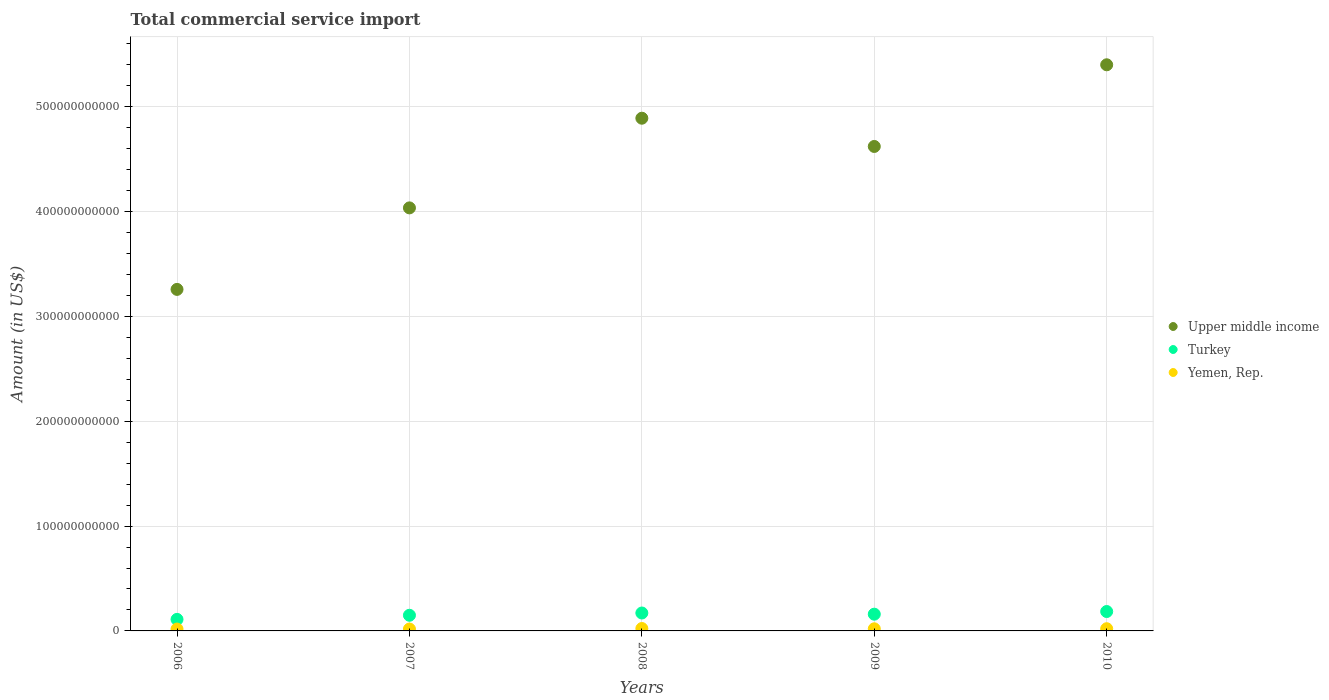How many different coloured dotlines are there?
Provide a succinct answer. 3. Is the number of dotlines equal to the number of legend labels?
Offer a very short reply. Yes. What is the total commercial service import in Turkey in 2008?
Provide a succinct answer. 1.71e+1. Across all years, what is the maximum total commercial service import in Yemen, Rep.?
Your answer should be compact. 2.29e+09. Across all years, what is the minimum total commercial service import in Upper middle income?
Keep it short and to the point. 3.26e+11. In which year was the total commercial service import in Turkey minimum?
Give a very brief answer. 2006. What is the total total commercial service import in Yemen, Rep. in the graph?
Offer a terse response. 1.00e+1. What is the difference between the total commercial service import in Upper middle income in 2009 and that in 2010?
Your response must be concise. -7.79e+1. What is the difference between the total commercial service import in Yemen, Rep. in 2009 and the total commercial service import in Turkey in 2007?
Ensure brevity in your answer.  -1.29e+1. What is the average total commercial service import in Upper middle income per year?
Make the answer very short. 4.44e+11. In the year 2008, what is the difference between the total commercial service import in Yemen, Rep. and total commercial service import in Upper middle income?
Your answer should be compact. -4.87e+11. What is the ratio of the total commercial service import in Turkey in 2009 to that in 2010?
Your answer should be compact. 0.86. Is the total commercial service import in Yemen, Rep. in 2006 less than that in 2010?
Ensure brevity in your answer.  Yes. What is the difference between the highest and the second highest total commercial service import in Turkey?
Give a very brief answer. 1.42e+09. What is the difference between the highest and the lowest total commercial service import in Upper middle income?
Your response must be concise. 2.14e+11. Is the sum of the total commercial service import in Yemen, Rep. in 2008 and 2010 greater than the maximum total commercial service import in Turkey across all years?
Ensure brevity in your answer.  No. Is it the case that in every year, the sum of the total commercial service import in Yemen, Rep. and total commercial service import in Turkey  is greater than the total commercial service import in Upper middle income?
Give a very brief answer. No. Does the total commercial service import in Yemen, Rep. monotonically increase over the years?
Provide a short and direct response. No. Is the total commercial service import in Turkey strictly greater than the total commercial service import in Upper middle income over the years?
Keep it short and to the point. No. What is the difference between two consecutive major ticks on the Y-axis?
Your answer should be compact. 1.00e+11. Are the values on the major ticks of Y-axis written in scientific E-notation?
Keep it short and to the point. No. Where does the legend appear in the graph?
Make the answer very short. Center right. How are the legend labels stacked?
Give a very brief answer. Vertical. What is the title of the graph?
Offer a terse response. Total commercial service import. What is the Amount (in US$) in Upper middle income in 2006?
Offer a terse response. 3.26e+11. What is the Amount (in US$) in Turkey in 2006?
Your response must be concise. 1.10e+1. What is the Amount (in US$) in Yemen, Rep. in 2006?
Ensure brevity in your answer.  1.80e+09. What is the Amount (in US$) in Upper middle income in 2007?
Give a very brief answer. 4.04e+11. What is the Amount (in US$) of Turkey in 2007?
Offer a very short reply. 1.49e+1. What is the Amount (in US$) in Yemen, Rep. in 2007?
Your answer should be very brief. 1.81e+09. What is the Amount (in US$) of Upper middle income in 2008?
Provide a short and direct response. 4.89e+11. What is the Amount (in US$) of Turkey in 2008?
Your answer should be very brief. 1.71e+1. What is the Amount (in US$) in Yemen, Rep. in 2008?
Give a very brief answer. 2.29e+09. What is the Amount (in US$) in Upper middle income in 2009?
Offer a terse response. 4.62e+11. What is the Amount (in US$) in Turkey in 2009?
Make the answer very short. 1.60e+1. What is the Amount (in US$) of Yemen, Rep. in 2009?
Your answer should be compact. 2.03e+09. What is the Amount (in US$) of Upper middle income in 2010?
Ensure brevity in your answer.  5.40e+11. What is the Amount (in US$) of Turkey in 2010?
Keep it short and to the point. 1.85e+1. What is the Amount (in US$) of Yemen, Rep. in 2010?
Give a very brief answer. 2.10e+09. Across all years, what is the maximum Amount (in US$) in Upper middle income?
Your answer should be compact. 5.40e+11. Across all years, what is the maximum Amount (in US$) in Turkey?
Keep it short and to the point. 1.85e+1. Across all years, what is the maximum Amount (in US$) of Yemen, Rep.?
Provide a succinct answer. 2.29e+09. Across all years, what is the minimum Amount (in US$) of Upper middle income?
Keep it short and to the point. 3.26e+11. Across all years, what is the minimum Amount (in US$) in Turkey?
Ensure brevity in your answer.  1.10e+1. Across all years, what is the minimum Amount (in US$) of Yemen, Rep.?
Ensure brevity in your answer.  1.80e+09. What is the total Amount (in US$) in Upper middle income in the graph?
Your answer should be very brief. 2.22e+12. What is the total Amount (in US$) in Turkey in the graph?
Give a very brief answer. 7.75e+1. What is the total Amount (in US$) in Yemen, Rep. in the graph?
Your answer should be compact. 1.00e+1. What is the difference between the Amount (in US$) of Upper middle income in 2006 and that in 2007?
Make the answer very short. -7.78e+1. What is the difference between the Amount (in US$) in Turkey in 2006 and that in 2007?
Your answer should be compact. -3.92e+09. What is the difference between the Amount (in US$) in Yemen, Rep. in 2006 and that in 2007?
Your answer should be very brief. -1.06e+07. What is the difference between the Amount (in US$) in Upper middle income in 2006 and that in 2008?
Ensure brevity in your answer.  -1.63e+11. What is the difference between the Amount (in US$) of Turkey in 2006 and that in 2008?
Your response must be concise. -6.08e+09. What is the difference between the Amount (in US$) of Yemen, Rep. in 2006 and that in 2008?
Ensure brevity in your answer.  -4.89e+08. What is the difference between the Amount (in US$) of Upper middle income in 2006 and that in 2009?
Make the answer very short. -1.36e+11. What is the difference between the Amount (in US$) of Turkey in 2006 and that in 2009?
Provide a short and direct response. -4.95e+09. What is the difference between the Amount (in US$) in Yemen, Rep. in 2006 and that in 2009?
Provide a succinct answer. -2.25e+08. What is the difference between the Amount (in US$) in Upper middle income in 2006 and that in 2010?
Keep it short and to the point. -2.14e+11. What is the difference between the Amount (in US$) in Turkey in 2006 and that in 2010?
Provide a succinct answer. -7.49e+09. What is the difference between the Amount (in US$) of Yemen, Rep. in 2006 and that in 2010?
Ensure brevity in your answer.  -3.02e+08. What is the difference between the Amount (in US$) of Upper middle income in 2007 and that in 2008?
Your response must be concise. -8.55e+1. What is the difference between the Amount (in US$) in Turkey in 2007 and that in 2008?
Provide a succinct answer. -2.16e+09. What is the difference between the Amount (in US$) of Yemen, Rep. in 2007 and that in 2008?
Provide a short and direct response. -4.78e+08. What is the difference between the Amount (in US$) in Upper middle income in 2007 and that in 2009?
Your response must be concise. -5.86e+1. What is the difference between the Amount (in US$) of Turkey in 2007 and that in 2009?
Offer a terse response. -1.04e+09. What is the difference between the Amount (in US$) of Yemen, Rep. in 2007 and that in 2009?
Make the answer very short. -2.14e+08. What is the difference between the Amount (in US$) in Upper middle income in 2007 and that in 2010?
Offer a very short reply. -1.37e+11. What is the difference between the Amount (in US$) of Turkey in 2007 and that in 2010?
Ensure brevity in your answer.  -3.57e+09. What is the difference between the Amount (in US$) of Yemen, Rep. in 2007 and that in 2010?
Ensure brevity in your answer.  -2.92e+08. What is the difference between the Amount (in US$) of Upper middle income in 2008 and that in 2009?
Ensure brevity in your answer.  2.69e+1. What is the difference between the Amount (in US$) in Turkey in 2008 and that in 2009?
Offer a terse response. 1.12e+09. What is the difference between the Amount (in US$) of Yemen, Rep. in 2008 and that in 2009?
Keep it short and to the point. 2.64e+08. What is the difference between the Amount (in US$) in Upper middle income in 2008 and that in 2010?
Your response must be concise. -5.10e+1. What is the difference between the Amount (in US$) of Turkey in 2008 and that in 2010?
Offer a terse response. -1.42e+09. What is the difference between the Amount (in US$) of Yemen, Rep. in 2008 and that in 2010?
Make the answer very short. 1.86e+08. What is the difference between the Amount (in US$) in Upper middle income in 2009 and that in 2010?
Offer a very short reply. -7.79e+1. What is the difference between the Amount (in US$) in Turkey in 2009 and that in 2010?
Your response must be concise. -2.54e+09. What is the difference between the Amount (in US$) in Yemen, Rep. in 2009 and that in 2010?
Give a very brief answer. -7.75e+07. What is the difference between the Amount (in US$) in Upper middle income in 2006 and the Amount (in US$) in Turkey in 2007?
Ensure brevity in your answer.  3.11e+11. What is the difference between the Amount (in US$) of Upper middle income in 2006 and the Amount (in US$) of Yemen, Rep. in 2007?
Your answer should be very brief. 3.24e+11. What is the difference between the Amount (in US$) in Turkey in 2006 and the Amount (in US$) in Yemen, Rep. in 2007?
Make the answer very short. 9.21e+09. What is the difference between the Amount (in US$) of Upper middle income in 2006 and the Amount (in US$) of Turkey in 2008?
Your answer should be very brief. 3.09e+11. What is the difference between the Amount (in US$) of Upper middle income in 2006 and the Amount (in US$) of Yemen, Rep. in 2008?
Provide a short and direct response. 3.24e+11. What is the difference between the Amount (in US$) of Turkey in 2006 and the Amount (in US$) of Yemen, Rep. in 2008?
Provide a short and direct response. 8.73e+09. What is the difference between the Amount (in US$) in Upper middle income in 2006 and the Amount (in US$) in Turkey in 2009?
Your answer should be compact. 3.10e+11. What is the difference between the Amount (in US$) in Upper middle income in 2006 and the Amount (in US$) in Yemen, Rep. in 2009?
Your answer should be very brief. 3.24e+11. What is the difference between the Amount (in US$) of Turkey in 2006 and the Amount (in US$) of Yemen, Rep. in 2009?
Offer a terse response. 8.99e+09. What is the difference between the Amount (in US$) of Upper middle income in 2006 and the Amount (in US$) of Turkey in 2010?
Provide a short and direct response. 3.07e+11. What is the difference between the Amount (in US$) of Upper middle income in 2006 and the Amount (in US$) of Yemen, Rep. in 2010?
Your answer should be compact. 3.24e+11. What is the difference between the Amount (in US$) in Turkey in 2006 and the Amount (in US$) in Yemen, Rep. in 2010?
Keep it short and to the point. 8.91e+09. What is the difference between the Amount (in US$) in Upper middle income in 2007 and the Amount (in US$) in Turkey in 2008?
Keep it short and to the point. 3.86e+11. What is the difference between the Amount (in US$) of Upper middle income in 2007 and the Amount (in US$) of Yemen, Rep. in 2008?
Your answer should be very brief. 4.01e+11. What is the difference between the Amount (in US$) in Turkey in 2007 and the Amount (in US$) in Yemen, Rep. in 2008?
Ensure brevity in your answer.  1.26e+1. What is the difference between the Amount (in US$) in Upper middle income in 2007 and the Amount (in US$) in Turkey in 2009?
Ensure brevity in your answer.  3.88e+11. What is the difference between the Amount (in US$) in Upper middle income in 2007 and the Amount (in US$) in Yemen, Rep. in 2009?
Your response must be concise. 4.02e+11. What is the difference between the Amount (in US$) in Turkey in 2007 and the Amount (in US$) in Yemen, Rep. in 2009?
Keep it short and to the point. 1.29e+1. What is the difference between the Amount (in US$) of Upper middle income in 2007 and the Amount (in US$) of Turkey in 2010?
Your answer should be compact. 3.85e+11. What is the difference between the Amount (in US$) in Upper middle income in 2007 and the Amount (in US$) in Yemen, Rep. in 2010?
Make the answer very short. 4.01e+11. What is the difference between the Amount (in US$) in Turkey in 2007 and the Amount (in US$) in Yemen, Rep. in 2010?
Keep it short and to the point. 1.28e+1. What is the difference between the Amount (in US$) of Upper middle income in 2008 and the Amount (in US$) of Turkey in 2009?
Provide a short and direct response. 4.73e+11. What is the difference between the Amount (in US$) in Upper middle income in 2008 and the Amount (in US$) in Yemen, Rep. in 2009?
Make the answer very short. 4.87e+11. What is the difference between the Amount (in US$) of Turkey in 2008 and the Amount (in US$) of Yemen, Rep. in 2009?
Ensure brevity in your answer.  1.51e+1. What is the difference between the Amount (in US$) of Upper middle income in 2008 and the Amount (in US$) of Turkey in 2010?
Give a very brief answer. 4.71e+11. What is the difference between the Amount (in US$) in Upper middle income in 2008 and the Amount (in US$) in Yemen, Rep. in 2010?
Give a very brief answer. 4.87e+11. What is the difference between the Amount (in US$) in Turkey in 2008 and the Amount (in US$) in Yemen, Rep. in 2010?
Keep it short and to the point. 1.50e+1. What is the difference between the Amount (in US$) of Upper middle income in 2009 and the Amount (in US$) of Turkey in 2010?
Offer a very short reply. 4.44e+11. What is the difference between the Amount (in US$) in Upper middle income in 2009 and the Amount (in US$) in Yemen, Rep. in 2010?
Your response must be concise. 4.60e+11. What is the difference between the Amount (in US$) in Turkey in 2009 and the Amount (in US$) in Yemen, Rep. in 2010?
Offer a terse response. 1.39e+1. What is the average Amount (in US$) of Upper middle income per year?
Make the answer very short. 4.44e+11. What is the average Amount (in US$) in Turkey per year?
Ensure brevity in your answer.  1.55e+1. What is the average Amount (in US$) of Yemen, Rep. per year?
Offer a very short reply. 2.01e+09. In the year 2006, what is the difference between the Amount (in US$) in Upper middle income and Amount (in US$) in Turkey?
Keep it short and to the point. 3.15e+11. In the year 2006, what is the difference between the Amount (in US$) of Upper middle income and Amount (in US$) of Yemen, Rep.?
Offer a terse response. 3.24e+11. In the year 2006, what is the difference between the Amount (in US$) in Turkey and Amount (in US$) in Yemen, Rep.?
Give a very brief answer. 9.22e+09. In the year 2007, what is the difference between the Amount (in US$) of Upper middle income and Amount (in US$) of Turkey?
Give a very brief answer. 3.89e+11. In the year 2007, what is the difference between the Amount (in US$) in Upper middle income and Amount (in US$) in Yemen, Rep.?
Provide a succinct answer. 4.02e+11. In the year 2007, what is the difference between the Amount (in US$) in Turkey and Amount (in US$) in Yemen, Rep.?
Your response must be concise. 1.31e+1. In the year 2008, what is the difference between the Amount (in US$) of Upper middle income and Amount (in US$) of Turkey?
Your answer should be compact. 4.72e+11. In the year 2008, what is the difference between the Amount (in US$) in Upper middle income and Amount (in US$) in Yemen, Rep.?
Offer a very short reply. 4.87e+11. In the year 2008, what is the difference between the Amount (in US$) in Turkey and Amount (in US$) in Yemen, Rep.?
Your response must be concise. 1.48e+1. In the year 2009, what is the difference between the Amount (in US$) in Upper middle income and Amount (in US$) in Turkey?
Offer a very short reply. 4.46e+11. In the year 2009, what is the difference between the Amount (in US$) of Upper middle income and Amount (in US$) of Yemen, Rep.?
Offer a very short reply. 4.60e+11. In the year 2009, what is the difference between the Amount (in US$) in Turkey and Amount (in US$) in Yemen, Rep.?
Provide a succinct answer. 1.39e+1. In the year 2010, what is the difference between the Amount (in US$) in Upper middle income and Amount (in US$) in Turkey?
Offer a very short reply. 5.22e+11. In the year 2010, what is the difference between the Amount (in US$) of Upper middle income and Amount (in US$) of Yemen, Rep.?
Provide a short and direct response. 5.38e+11. In the year 2010, what is the difference between the Amount (in US$) of Turkey and Amount (in US$) of Yemen, Rep.?
Ensure brevity in your answer.  1.64e+1. What is the ratio of the Amount (in US$) of Upper middle income in 2006 to that in 2007?
Offer a terse response. 0.81. What is the ratio of the Amount (in US$) in Turkey in 2006 to that in 2007?
Your answer should be very brief. 0.74. What is the ratio of the Amount (in US$) in Upper middle income in 2006 to that in 2008?
Provide a succinct answer. 0.67. What is the ratio of the Amount (in US$) of Turkey in 2006 to that in 2008?
Keep it short and to the point. 0.64. What is the ratio of the Amount (in US$) in Yemen, Rep. in 2006 to that in 2008?
Keep it short and to the point. 0.79. What is the ratio of the Amount (in US$) of Upper middle income in 2006 to that in 2009?
Offer a terse response. 0.7. What is the ratio of the Amount (in US$) of Turkey in 2006 to that in 2009?
Provide a short and direct response. 0.69. What is the ratio of the Amount (in US$) of Upper middle income in 2006 to that in 2010?
Keep it short and to the point. 0.6. What is the ratio of the Amount (in US$) of Turkey in 2006 to that in 2010?
Your answer should be compact. 0.6. What is the ratio of the Amount (in US$) of Yemen, Rep. in 2006 to that in 2010?
Your response must be concise. 0.86. What is the ratio of the Amount (in US$) in Upper middle income in 2007 to that in 2008?
Your answer should be very brief. 0.83. What is the ratio of the Amount (in US$) of Turkey in 2007 to that in 2008?
Your answer should be very brief. 0.87. What is the ratio of the Amount (in US$) of Yemen, Rep. in 2007 to that in 2008?
Make the answer very short. 0.79. What is the ratio of the Amount (in US$) in Upper middle income in 2007 to that in 2009?
Make the answer very short. 0.87. What is the ratio of the Amount (in US$) in Turkey in 2007 to that in 2009?
Keep it short and to the point. 0.94. What is the ratio of the Amount (in US$) in Yemen, Rep. in 2007 to that in 2009?
Ensure brevity in your answer.  0.89. What is the ratio of the Amount (in US$) in Upper middle income in 2007 to that in 2010?
Your answer should be very brief. 0.75. What is the ratio of the Amount (in US$) in Turkey in 2007 to that in 2010?
Ensure brevity in your answer.  0.81. What is the ratio of the Amount (in US$) in Yemen, Rep. in 2007 to that in 2010?
Your response must be concise. 0.86. What is the ratio of the Amount (in US$) of Upper middle income in 2008 to that in 2009?
Your answer should be very brief. 1.06. What is the ratio of the Amount (in US$) of Turkey in 2008 to that in 2009?
Your answer should be very brief. 1.07. What is the ratio of the Amount (in US$) of Yemen, Rep. in 2008 to that in 2009?
Make the answer very short. 1.13. What is the ratio of the Amount (in US$) in Upper middle income in 2008 to that in 2010?
Provide a succinct answer. 0.91. What is the ratio of the Amount (in US$) in Turkey in 2008 to that in 2010?
Give a very brief answer. 0.92. What is the ratio of the Amount (in US$) of Yemen, Rep. in 2008 to that in 2010?
Ensure brevity in your answer.  1.09. What is the ratio of the Amount (in US$) in Upper middle income in 2009 to that in 2010?
Your response must be concise. 0.86. What is the ratio of the Amount (in US$) in Turkey in 2009 to that in 2010?
Your response must be concise. 0.86. What is the ratio of the Amount (in US$) in Yemen, Rep. in 2009 to that in 2010?
Make the answer very short. 0.96. What is the difference between the highest and the second highest Amount (in US$) of Upper middle income?
Provide a succinct answer. 5.10e+1. What is the difference between the highest and the second highest Amount (in US$) in Turkey?
Your response must be concise. 1.42e+09. What is the difference between the highest and the second highest Amount (in US$) of Yemen, Rep.?
Give a very brief answer. 1.86e+08. What is the difference between the highest and the lowest Amount (in US$) of Upper middle income?
Your answer should be compact. 2.14e+11. What is the difference between the highest and the lowest Amount (in US$) in Turkey?
Give a very brief answer. 7.49e+09. What is the difference between the highest and the lowest Amount (in US$) of Yemen, Rep.?
Make the answer very short. 4.89e+08. 